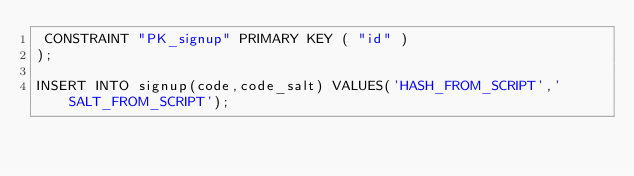Convert code to text. <code><loc_0><loc_0><loc_500><loc_500><_SQL_> CONSTRAINT "PK_signup" PRIMARY KEY ( "id" )
);

INSERT INTO signup(code,code_salt) VALUES('HASH_FROM_SCRIPT','SALT_FROM_SCRIPT');</code> 